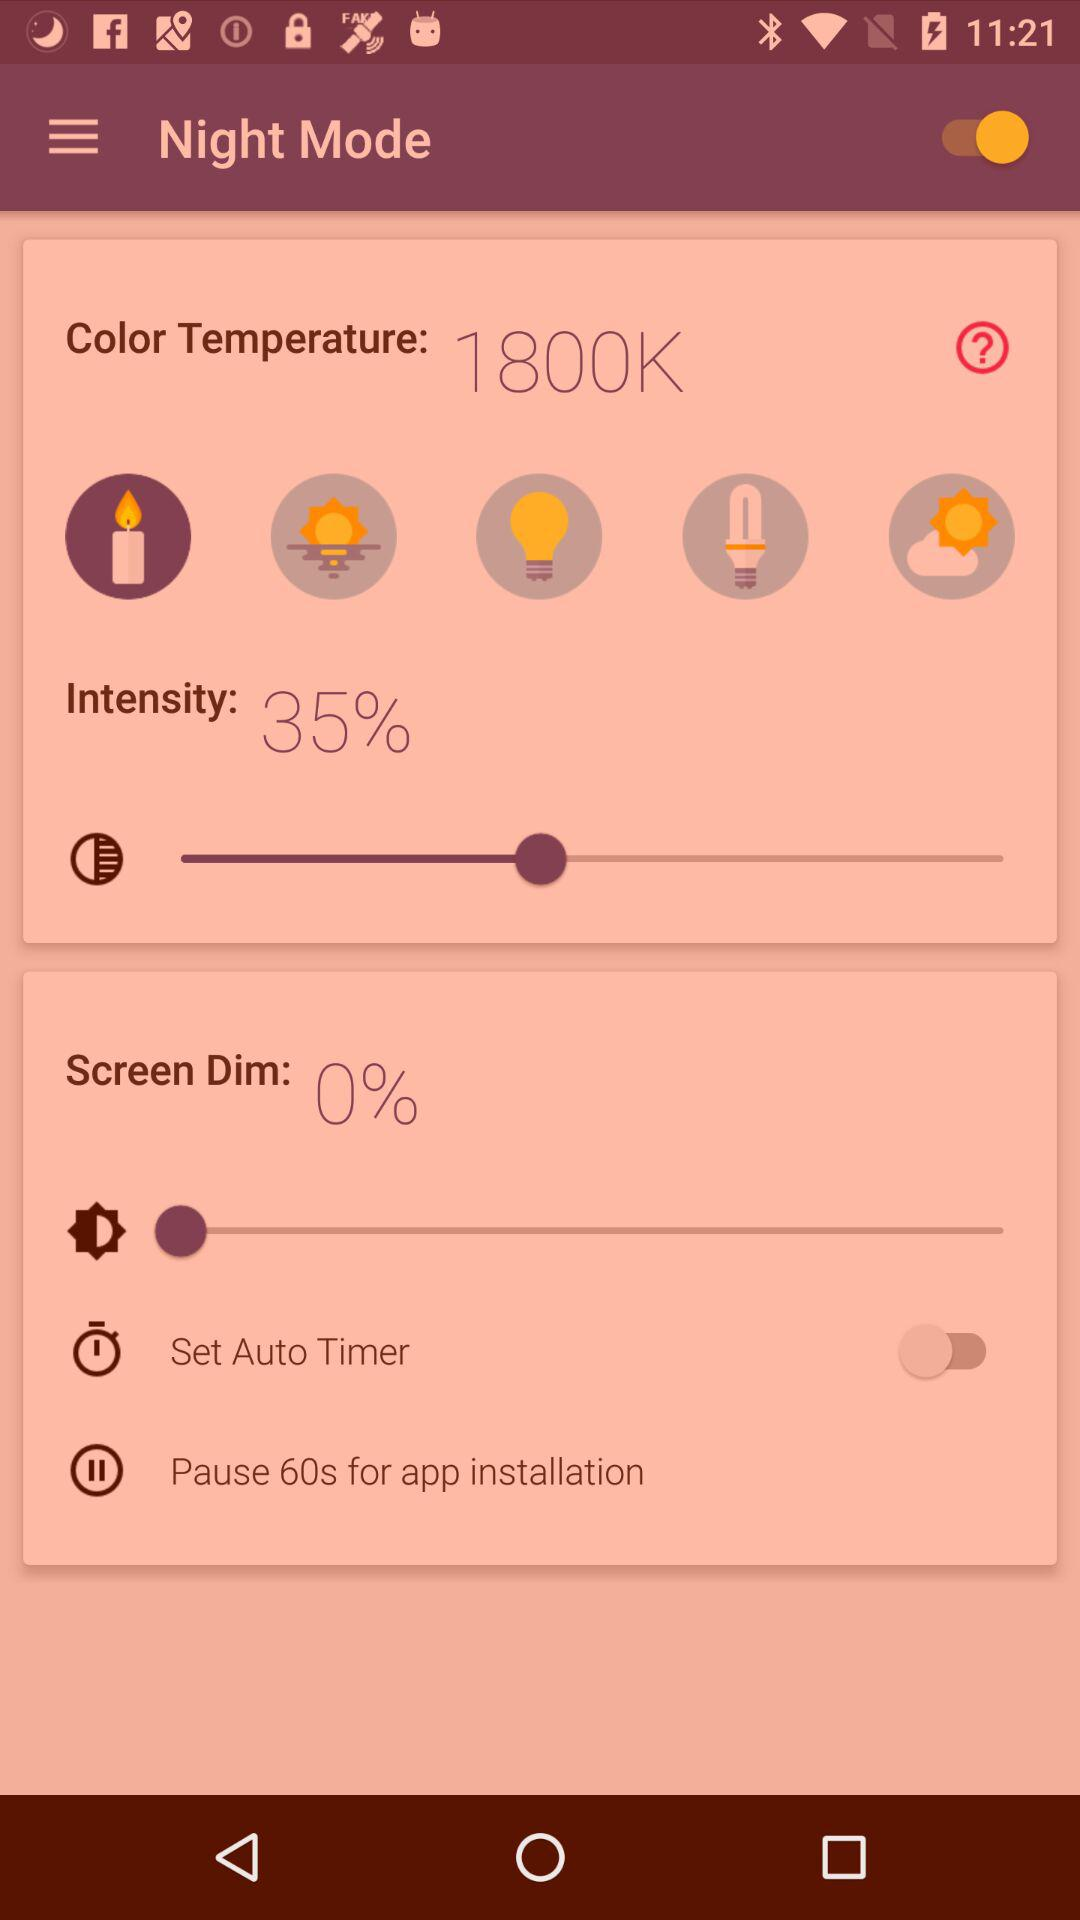What is the color temperature? The color temperature is 1800K. 